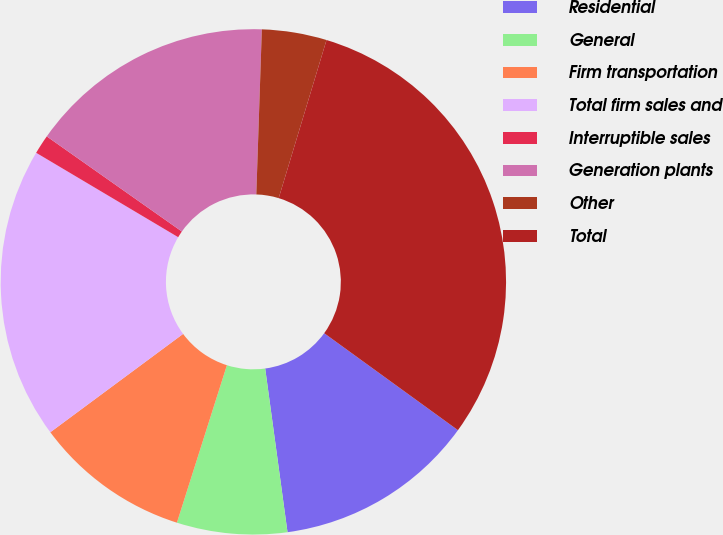<chart> <loc_0><loc_0><loc_500><loc_500><pie_chart><fcel>Residential<fcel>General<fcel>Firm transportation<fcel>Total firm sales and<fcel>Interruptible sales<fcel>Generation plants<fcel>Other<fcel>Total<nl><fcel>12.86%<fcel>7.05%<fcel>9.96%<fcel>18.68%<fcel>1.23%<fcel>15.77%<fcel>4.14%<fcel>30.31%<nl></chart> 